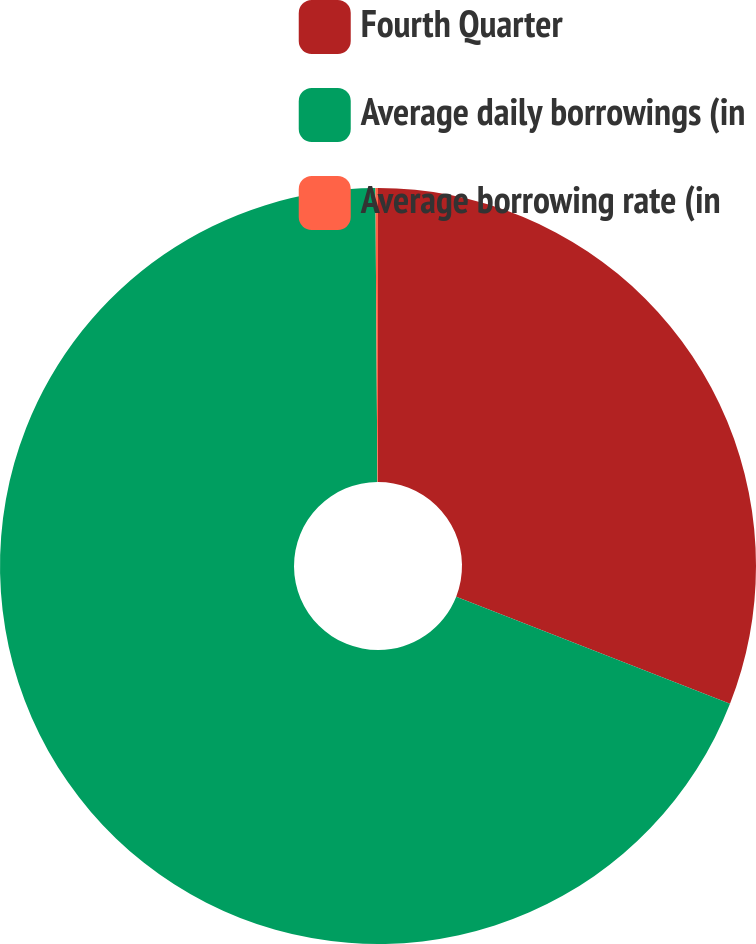<chart> <loc_0><loc_0><loc_500><loc_500><pie_chart><fcel>Fourth Quarter<fcel>Average daily borrowings (in<fcel>Average borrowing rate (in<nl><fcel>30.94%<fcel>68.95%<fcel>0.11%<nl></chart> 